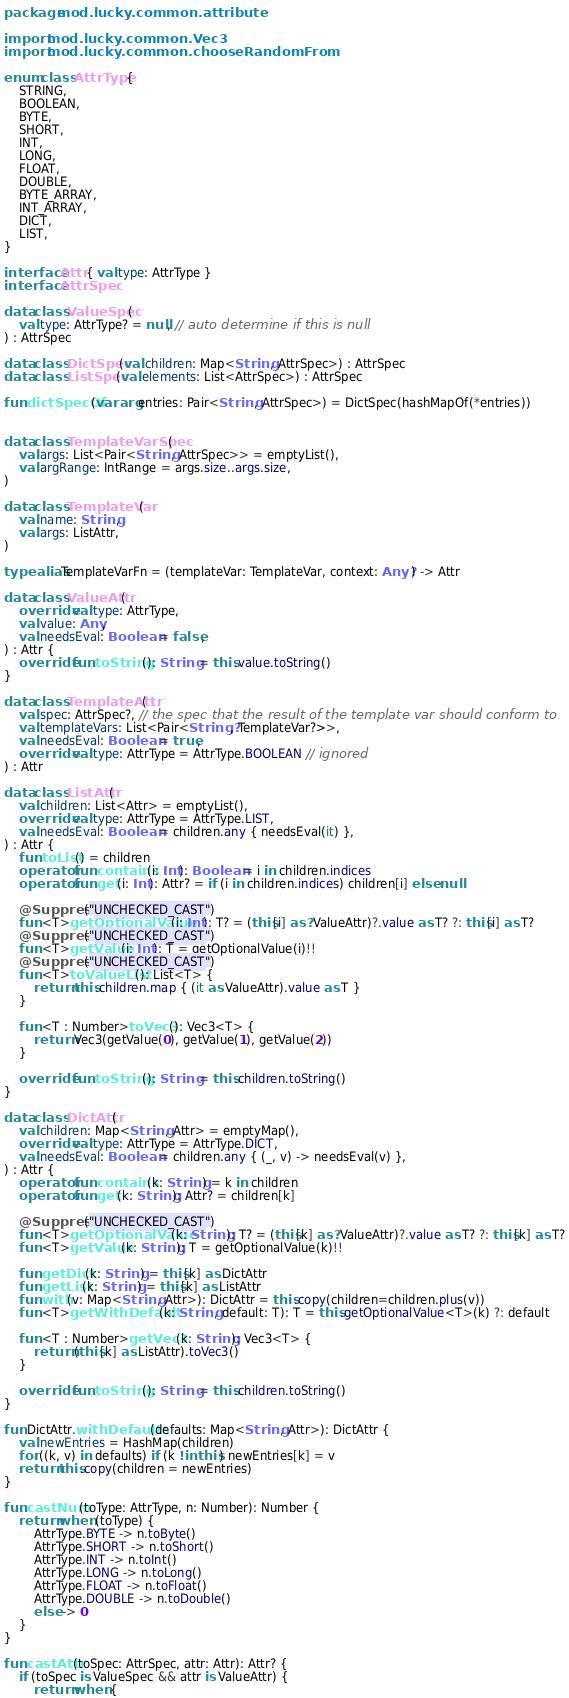<code> <loc_0><loc_0><loc_500><loc_500><_Kotlin_>package mod.lucky.common.attribute

import mod.lucky.common.Vec3
import mod.lucky.common.chooseRandomFrom

enum class AttrType {
    STRING,
    BOOLEAN,
    BYTE,
    SHORT,
    INT,
    LONG,
    FLOAT,
    DOUBLE,
    BYTE_ARRAY,
    INT_ARRAY,
    DICT,
    LIST,
}

interface Attr { val type: AttrType }
interface AttrSpec

data class ValueSpec(
    val type: AttrType? = null, // auto determine if this is null
) : AttrSpec

data class DictSpec(val children: Map<String, AttrSpec>) : AttrSpec
data class ListSpec(val elements: List<AttrSpec>) : AttrSpec

fun dictSpecOf(vararg entries: Pair<String, AttrSpec>) = DictSpec(hashMapOf(*entries))


data class TemplateVarSpec(
    val args: List<Pair<String, AttrSpec>> = emptyList(),
    val argRange: IntRange = args.size..args.size,
)

data class TemplateVar(
    val name: String,
    val args: ListAttr,
)

typealias TemplateVarFn = (templateVar: TemplateVar, context: Any?) -> Attr

data class ValueAttr(
    override val type: AttrType,
    val value: Any,
    val needsEval: Boolean = false,
) : Attr {
    override fun toString(): String = this.value.toString()
}

data class TemplateAttr(
    val spec: AttrSpec?, // the spec that the result of the template var should conform to
    val templateVars: List<Pair<String?, TemplateVar?>>,
    val needsEval: Boolean = true,
    override val type: AttrType = AttrType.BOOLEAN // ignored
) : Attr

data class ListAttr(
    val children: List<Attr> = emptyList(),
    override val type: AttrType = AttrType.LIST,
    val needsEval: Boolean = children.any { needsEval(it) },
) : Attr {
    fun toList() = children
    operator fun contains(i: Int): Boolean = i in children.indices
    operator fun get(i: Int): Attr? = if (i in children.indices) children[i] else null

    @Suppress("UNCHECKED_CAST")
    fun <T>getOptionalValue(i: Int): T? = (this[i] as? ValueAttr)?.value as T? ?: this[i] as T?
    @Suppress("UNCHECKED_CAST")
    fun <T>getValue(i: Int): T = getOptionalValue(i)!!
    @Suppress("UNCHECKED_CAST")
    fun <T>toValueList(): List<T> {
        return this.children.map { (it as ValueAttr).value as T }
    }

    fun <T : Number>toVec3(): Vec3<T> {
        return Vec3(getValue(0), getValue(1), getValue(2))
    }

    override fun toString(): String = this.children.toString()
}

data class DictAttr(
    val children: Map<String, Attr> = emptyMap(),
    override val type: AttrType = AttrType.DICT,
    val needsEval: Boolean = children.any { (_, v) -> needsEval(v) },
) : Attr {
    operator fun contains(k: String) = k in children
    operator fun get(k: String): Attr? = children[k]

    @Suppress("UNCHECKED_CAST")
    fun <T>getOptionalValue(k: String): T? = (this[k] as? ValueAttr)?.value as T? ?: this[k] as T?
    fun <T>getValue(k: String): T = getOptionalValue(k)!!

    fun getDict(k: String) = this[k] as DictAttr
    fun getList(k: String) = this[k] as ListAttr
    fun with(v: Map<String, Attr>): DictAttr = this.copy(children=children.plus(v))
    fun <T>getWithDefault(k: String, default: T): T = this.getOptionalValue<T>(k) ?: default

    fun <T : Number>getVec3(k: String): Vec3<T> {
        return (this[k] as ListAttr).toVec3()
    }

    override fun toString(): String = this.children.toString()
}

fun DictAttr.withDefaults(defaults: Map<String, Attr>): DictAttr {
    val newEntries = HashMap(children)
    for ((k, v) in defaults) if (k !in this) newEntries[k] = v
    return this.copy(children = newEntries)
}

fun castNum(toType: AttrType, n: Number): Number {
    return when (toType) {
        AttrType.BYTE -> n.toByte()
        AttrType.SHORT -> n.toShort()
        AttrType.INT -> n.toInt()
        AttrType.LONG -> n.toLong()
        AttrType.FLOAT -> n.toFloat()
        AttrType.DOUBLE -> n.toDouble()
        else -> 0
    }
}

fun castAttr(toSpec: AttrSpec, attr: Attr): Attr? {
    if (toSpec is ValueSpec && attr is ValueAttr) {
        return when {</code> 